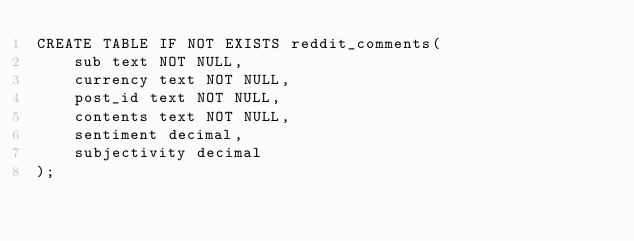Convert code to text. <code><loc_0><loc_0><loc_500><loc_500><_SQL_>CREATE TABLE IF NOT EXISTS reddit_comments(
	sub text NOT NULL,
	currency text NOT NULL,
	post_id text NOT NULL,
	contents text NOT NULL,
	sentiment decimal,
	subjectivity decimal
);
</code> 